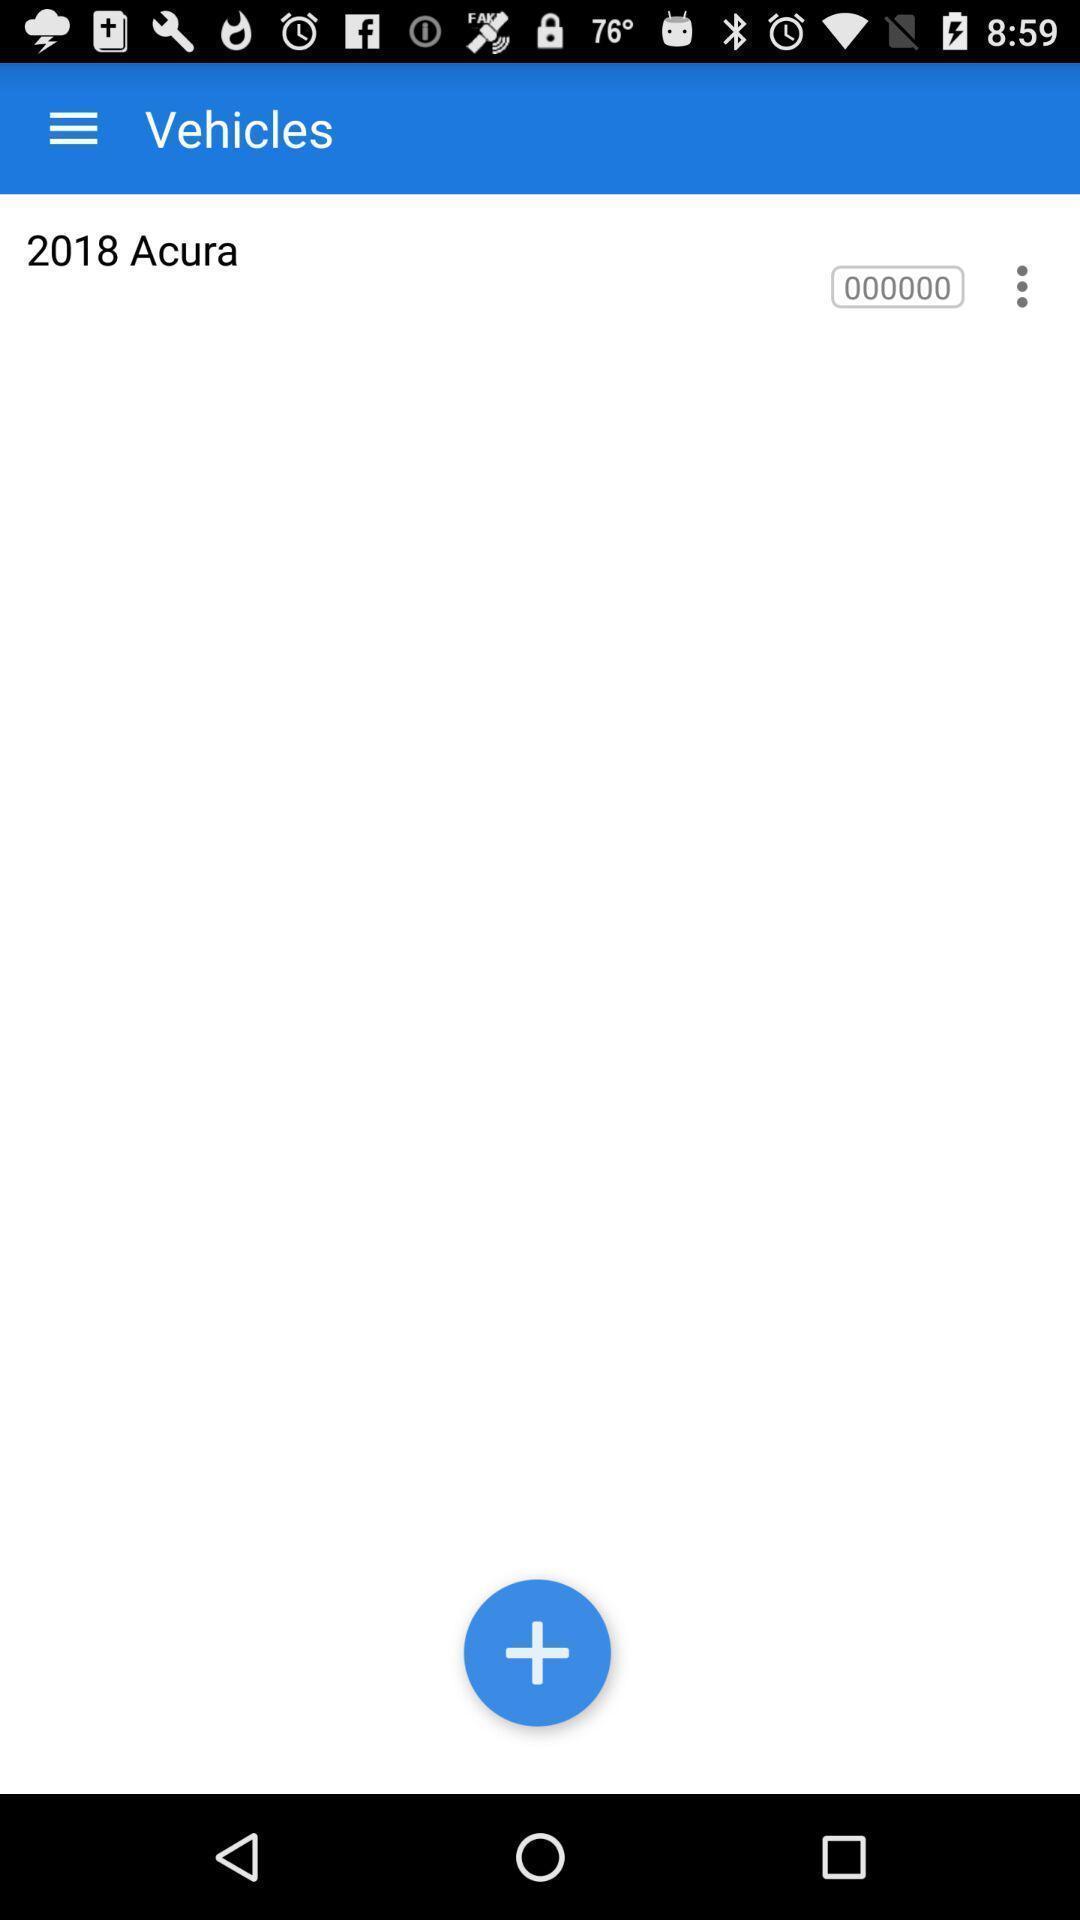What details can you identify in this image? Screen displaying vehicle information with addon icon. 